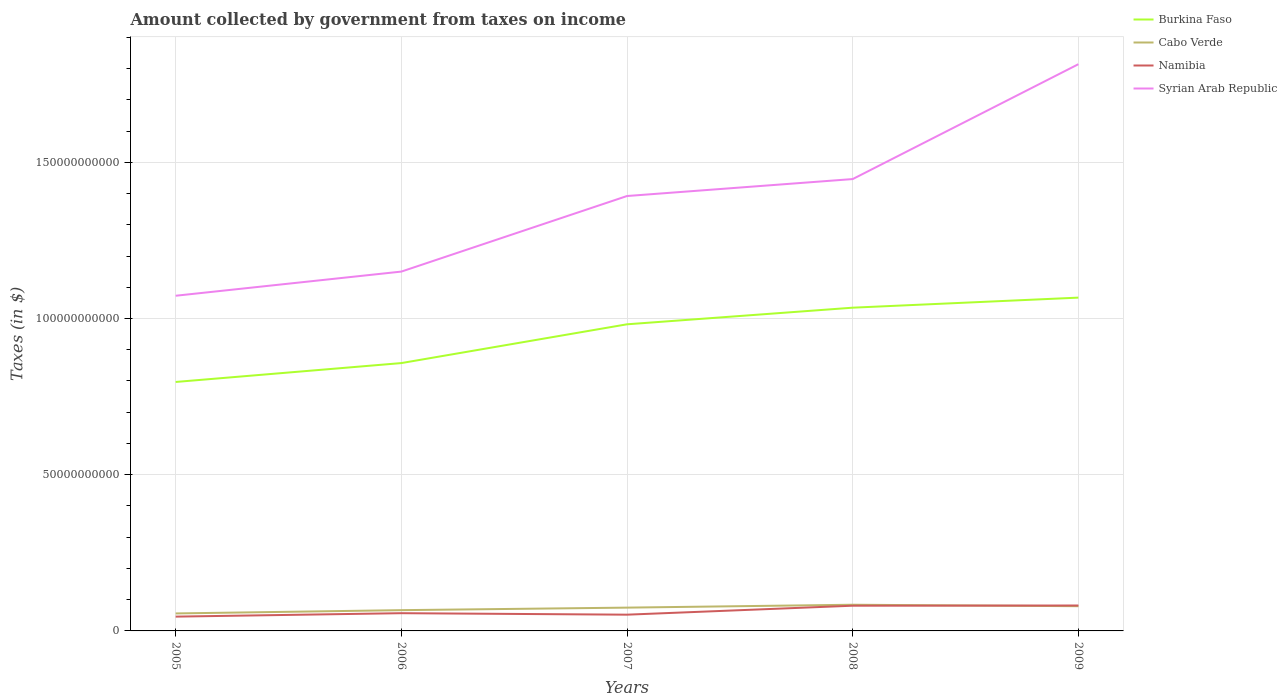How many different coloured lines are there?
Your answer should be very brief. 4. Does the line corresponding to Syrian Arab Republic intersect with the line corresponding to Namibia?
Ensure brevity in your answer.  No. Is the number of lines equal to the number of legend labels?
Ensure brevity in your answer.  Yes. Across all years, what is the maximum amount collected by government from taxes on income in Cabo Verde?
Keep it short and to the point. 5.60e+09. What is the total amount collected by government from taxes on income in Burkina Faso in the graph?
Ensure brevity in your answer.  -1.85e+1. What is the difference between the highest and the second highest amount collected by government from taxes on income in Syrian Arab Republic?
Keep it short and to the point. 7.41e+1. Is the amount collected by government from taxes on income in Cabo Verde strictly greater than the amount collected by government from taxes on income in Namibia over the years?
Provide a short and direct response. No. How many lines are there?
Offer a very short reply. 4. Are the values on the major ticks of Y-axis written in scientific E-notation?
Your answer should be very brief. No. Does the graph contain any zero values?
Provide a short and direct response. No. Where does the legend appear in the graph?
Your answer should be compact. Top right. How many legend labels are there?
Offer a very short reply. 4. What is the title of the graph?
Provide a short and direct response. Amount collected by government from taxes on income. Does "Singapore" appear as one of the legend labels in the graph?
Keep it short and to the point. No. What is the label or title of the Y-axis?
Keep it short and to the point. Taxes (in $). What is the Taxes (in $) of Burkina Faso in 2005?
Your response must be concise. 7.97e+1. What is the Taxes (in $) of Cabo Verde in 2005?
Offer a very short reply. 5.60e+09. What is the Taxes (in $) of Namibia in 2005?
Provide a succinct answer. 4.58e+09. What is the Taxes (in $) in Syrian Arab Republic in 2005?
Your answer should be compact. 1.07e+11. What is the Taxes (in $) in Burkina Faso in 2006?
Ensure brevity in your answer.  8.57e+1. What is the Taxes (in $) of Cabo Verde in 2006?
Give a very brief answer. 6.65e+09. What is the Taxes (in $) of Namibia in 2006?
Your response must be concise. 5.68e+09. What is the Taxes (in $) of Syrian Arab Republic in 2006?
Offer a terse response. 1.15e+11. What is the Taxes (in $) of Burkina Faso in 2007?
Offer a very short reply. 9.82e+1. What is the Taxes (in $) in Cabo Verde in 2007?
Offer a terse response. 7.46e+09. What is the Taxes (in $) of Namibia in 2007?
Your response must be concise. 5.20e+09. What is the Taxes (in $) of Syrian Arab Republic in 2007?
Make the answer very short. 1.39e+11. What is the Taxes (in $) in Burkina Faso in 2008?
Offer a terse response. 1.03e+11. What is the Taxes (in $) of Cabo Verde in 2008?
Your answer should be compact. 8.38e+09. What is the Taxes (in $) of Namibia in 2008?
Provide a succinct answer. 8.07e+09. What is the Taxes (in $) in Syrian Arab Republic in 2008?
Offer a very short reply. 1.45e+11. What is the Taxes (in $) of Burkina Faso in 2009?
Make the answer very short. 1.07e+11. What is the Taxes (in $) of Cabo Verde in 2009?
Make the answer very short. 7.91e+09. What is the Taxes (in $) in Namibia in 2009?
Your response must be concise. 8.14e+09. What is the Taxes (in $) of Syrian Arab Republic in 2009?
Make the answer very short. 1.81e+11. Across all years, what is the maximum Taxes (in $) in Burkina Faso?
Your response must be concise. 1.07e+11. Across all years, what is the maximum Taxes (in $) of Cabo Verde?
Offer a terse response. 8.38e+09. Across all years, what is the maximum Taxes (in $) of Namibia?
Your answer should be very brief. 8.14e+09. Across all years, what is the maximum Taxes (in $) of Syrian Arab Republic?
Your answer should be compact. 1.81e+11. Across all years, what is the minimum Taxes (in $) in Burkina Faso?
Offer a very short reply. 7.97e+1. Across all years, what is the minimum Taxes (in $) in Cabo Verde?
Ensure brevity in your answer.  5.60e+09. Across all years, what is the minimum Taxes (in $) of Namibia?
Make the answer very short. 4.58e+09. Across all years, what is the minimum Taxes (in $) in Syrian Arab Republic?
Provide a succinct answer. 1.07e+11. What is the total Taxes (in $) of Burkina Faso in the graph?
Your response must be concise. 4.74e+11. What is the total Taxes (in $) of Cabo Verde in the graph?
Make the answer very short. 3.60e+1. What is the total Taxes (in $) in Namibia in the graph?
Give a very brief answer. 3.17e+1. What is the total Taxes (in $) in Syrian Arab Republic in the graph?
Provide a short and direct response. 6.88e+11. What is the difference between the Taxes (in $) of Burkina Faso in 2005 and that in 2006?
Give a very brief answer. -6.05e+09. What is the difference between the Taxes (in $) of Cabo Verde in 2005 and that in 2006?
Give a very brief answer. -1.05e+09. What is the difference between the Taxes (in $) in Namibia in 2005 and that in 2006?
Give a very brief answer. -1.10e+09. What is the difference between the Taxes (in $) of Syrian Arab Republic in 2005 and that in 2006?
Your answer should be compact. -7.73e+09. What is the difference between the Taxes (in $) in Burkina Faso in 2005 and that in 2007?
Your response must be concise. -1.85e+1. What is the difference between the Taxes (in $) of Cabo Verde in 2005 and that in 2007?
Give a very brief answer. -1.86e+09. What is the difference between the Taxes (in $) in Namibia in 2005 and that in 2007?
Provide a succinct answer. -6.25e+08. What is the difference between the Taxes (in $) of Syrian Arab Republic in 2005 and that in 2007?
Provide a succinct answer. -3.19e+1. What is the difference between the Taxes (in $) of Burkina Faso in 2005 and that in 2008?
Provide a succinct answer. -2.38e+1. What is the difference between the Taxes (in $) in Cabo Verde in 2005 and that in 2008?
Give a very brief answer. -2.78e+09. What is the difference between the Taxes (in $) in Namibia in 2005 and that in 2008?
Provide a succinct answer. -3.49e+09. What is the difference between the Taxes (in $) in Syrian Arab Republic in 2005 and that in 2008?
Make the answer very short. -3.73e+1. What is the difference between the Taxes (in $) in Burkina Faso in 2005 and that in 2009?
Provide a short and direct response. -2.70e+1. What is the difference between the Taxes (in $) of Cabo Verde in 2005 and that in 2009?
Give a very brief answer. -2.31e+09. What is the difference between the Taxes (in $) of Namibia in 2005 and that in 2009?
Ensure brevity in your answer.  -3.56e+09. What is the difference between the Taxes (in $) in Syrian Arab Republic in 2005 and that in 2009?
Keep it short and to the point. -7.41e+1. What is the difference between the Taxes (in $) of Burkina Faso in 2006 and that in 2007?
Your answer should be compact. -1.24e+1. What is the difference between the Taxes (in $) in Cabo Verde in 2006 and that in 2007?
Keep it short and to the point. -8.07e+08. What is the difference between the Taxes (in $) in Namibia in 2006 and that in 2007?
Offer a terse response. 4.75e+08. What is the difference between the Taxes (in $) of Syrian Arab Republic in 2006 and that in 2007?
Your answer should be compact. -2.42e+1. What is the difference between the Taxes (in $) in Burkina Faso in 2006 and that in 2008?
Provide a short and direct response. -1.77e+1. What is the difference between the Taxes (in $) of Cabo Verde in 2006 and that in 2008?
Your response must be concise. -1.73e+09. What is the difference between the Taxes (in $) in Namibia in 2006 and that in 2008?
Your answer should be compact. -2.39e+09. What is the difference between the Taxes (in $) of Syrian Arab Republic in 2006 and that in 2008?
Make the answer very short. -2.96e+1. What is the difference between the Taxes (in $) in Burkina Faso in 2006 and that in 2009?
Your answer should be very brief. -2.09e+1. What is the difference between the Taxes (in $) in Cabo Verde in 2006 and that in 2009?
Offer a very short reply. -1.26e+09. What is the difference between the Taxes (in $) in Namibia in 2006 and that in 2009?
Provide a succinct answer. -2.46e+09. What is the difference between the Taxes (in $) in Syrian Arab Republic in 2006 and that in 2009?
Your answer should be very brief. -6.64e+1. What is the difference between the Taxes (in $) of Burkina Faso in 2007 and that in 2008?
Your answer should be compact. -5.32e+09. What is the difference between the Taxes (in $) in Cabo Verde in 2007 and that in 2008?
Your answer should be compact. -9.25e+08. What is the difference between the Taxes (in $) of Namibia in 2007 and that in 2008?
Your answer should be compact. -2.87e+09. What is the difference between the Taxes (in $) in Syrian Arab Republic in 2007 and that in 2008?
Keep it short and to the point. -5.43e+09. What is the difference between the Taxes (in $) of Burkina Faso in 2007 and that in 2009?
Your answer should be very brief. -8.54e+09. What is the difference between the Taxes (in $) of Cabo Verde in 2007 and that in 2009?
Your answer should be very brief. -4.55e+08. What is the difference between the Taxes (in $) in Namibia in 2007 and that in 2009?
Your answer should be very brief. -2.94e+09. What is the difference between the Taxes (in $) in Syrian Arab Republic in 2007 and that in 2009?
Your response must be concise. -4.22e+1. What is the difference between the Taxes (in $) of Burkina Faso in 2008 and that in 2009?
Your answer should be compact. -3.22e+09. What is the difference between the Taxes (in $) in Cabo Verde in 2008 and that in 2009?
Offer a very short reply. 4.70e+08. What is the difference between the Taxes (in $) of Namibia in 2008 and that in 2009?
Keep it short and to the point. -6.70e+07. What is the difference between the Taxes (in $) of Syrian Arab Republic in 2008 and that in 2009?
Offer a terse response. -3.68e+1. What is the difference between the Taxes (in $) in Burkina Faso in 2005 and the Taxes (in $) in Cabo Verde in 2006?
Make the answer very short. 7.30e+1. What is the difference between the Taxes (in $) of Burkina Faso in 2005 and the Taxes (in $) of Namibia in 2006?
Your response must be concise. 7.40e+1. What is the difference between the Taxes (in $) of Burkina Faso in 2005 and the Taxes (in $) of Syrian Arab Republic in 2006?
Offer a very short reply. -3.53e+1. What is the difference between the Taxes (in $) of Cabo Verde in 2005 and the Taxes (in $) of Namibia in 2006?
Your answer should be very brief. -7.93e+07. What is the difference between the Taxes (in $) in Cabo Verde in 2005 and the Taxes (in $) in Syrian Arab Republic in 2006?
Your answer should be compact. -1.09e+11. What is the difference between the Taxes (in $) in Namibia in 2005 and the Taxes (in $) in Syrian Arab Republic in 2006?
Ensure brevity in your answer.  -1.10e+11. What is the difference between the Taxes (in $) in Burkina Faso in 2005 and the Taxes (in $) in Cabo Verde in 2007?
Your answer should be very brief. 7.22e+1. What is the difference between the Taxes (in $) in Burkina Faso in 2005 and the Taxes (in $) in Namibia in 2007?
Your answer should be compact. 7.45e+1. What is the difference between the Taxes (in $) of Burkina Faso in 2005 and the Taxes (in $) of Syrian Arab Republic in 2007?
Your response must be concise. -5.95e+1. What is the difference between the Taxes (in $) of Cabo Verde in 2005 and the Taxes (in $) of Namibia in 2007?
Provide a succinct answer. 3.96e+08. What is the difference between the Taxes (in $) in Cabo Verde in 2005 and the Taxes (in $) in Syrian Arab Republic in 2007?
Your answer should be very brief. -1.34e+11. What is the difference between the Taxes (in $) in Namibia in 2005 and the Taxes (in $) in Syrian Arab Republic in 2007?
Your response must be concise. -1.35e+11. What is the difference between the Taxes (in $) of Burkina Faso in 2005 and the Taxes (in $) of Cabo Verde in 2008?
Your response must be concise. 7.13e+1. What is the difference between the Taxes (in $) in Burkina Faso in 2005 and the Taxes (in $) in Namibia in 2008?
Give a very brief answer. 7.16e+1. What is the difference between the Taxes (in $) in Burkina Faso in 2005 and the Taxes (in $) in Syrian Arab Republic in 2008?
Your answer should be compact. -6.49e+1. What is the difference between the Taxes (in $) in Cabo Verde in 2005 and the Taxes (in $) in Namibia in 2008?
Provide a succinct answer. -2.47e+09. What is the difference between the Taxes (in $) in Cabo Verde in 2005 and the Taxes (in $) in Syrian Arab Republic in 2008?
Keep it short and to the point. -1.39e+11. What is the difference between the Taxes (in $) of Namibia in 2005 and the Taxes (in $) of Syrian Arab Republic in 2008?
Your answer should be compact. -1.40e+11. What is the difference between the Taxes (in $) of Burkina Faso in 2005 and the Taxes (in $) of Cabo Verde in 2009?
Ensure brevity in your answer.  7.18e+1. What is the difference between the Taxes (in $) in Burkina Faso in 2005 and the Taxes (in $) in Namibia in 2009?
Offer a very short reply. 7.16e+1. What is the difference between the Taxes (in $) of Burkina Faso in 2005 and the Taxes (in $) of Syrian Arab Republic in 2009?
Make the answer very short. -1.02e+11. What is the difference between the Taxes (in $) of Cabo Verde in 2005 and the Taxes (in $) of Namibia in 2009?
Keep it short and to the point. -2.54e+09. What is the difference between the Taxes (in $) of Cabo Verde in 2005 and the Taxes (in $) of Syrian Arab Republic in 2009?
Keep it short and to the point. -1.76e+11. What is the difference between the Taxes (in $) of Namibia in 2005 and the Taxes (in $) of Syrian Arab Republic in 2009?
Make the answer very short. -1.77e+11. What is the difference between the Taxes (in $) of Burkina Faso in 2006 and the Taxes (in $) of Cabo Verde in 2007?
Your response must be concise. 7.83e+1. What is the difference between the Taxes (in $) in Burkina Faso in 2006 and the Taxes (in $) in Namibia in 2007?
Your answer should be compact. 8.05e+1. What is the difference between the Taxes (in $) in Burkina Faso in 2006 and the Taxes (in $) in Syrian Arab Republic in 2007?
Ensure brevity in your answer.  -5.35e+1. What is the difference between the Taxes (in $) in Cabo Verde in 2006 and the Taxes (in $) in Namibia in 2007?
Your response must be concise. 1.45e+09. What is the difference between the Taxes (in $) in Cabo Verde in 2006 and the Taxes (in $) in Syrian Arab Republic in 2007?
Ensure brevity in your answer.  -1.33e+11. What is the difference between the Taxes (in $) in Namibia in 2006 and the Taxes (in $) in Syrian Arab Republic in 2007?
Offer a very short reply. -1.34e+11. What is the difference between the Taxes (in $) of Burkina Faso in 2006 and the Taxes (in $) of Cabo Verde in 2008?
Make the answer very short. 7.74e+1. What is the difference between the Taxes (in $) of Burkina Faso in 2006 and the Taxes (in $) of Namibia in 2008?
Provide a succinct answer. 7.77e+1. What is the difference between the Taxes (in $) in Burkina Faso in 2006 and the Taxes (in $) in Syrian Arab Republic in 2008?
Give a very brief answer. -5.89e+1. What is the difference between the Taxes (in $) in Cabo Verde in 2006 and the Taxes (in $) in Namibia in 2008?
Keep it short and to the point. -1.42e+09. What is the difference between the Taxes (in $) in Cabo Verde in 2006 and the Taxes (in $) in Syrian Arab Republic in 2008?
Your answer should be very brief. -1.38e+11. What is the difference between the Taxes (in $) in Namibia in 2006 and the Taxes (in $) in Syrian Arab Republic in 2008?
Provide a succinct answer. -1.39e+11. What is the difference between the Taxes (in $) of Burkina Faso in 2006 and the Taxes (in $) of Cabo Verde in 2009?
Your answer should be very brief. 7.78e+1. What is the difference between the Taxes (in $) in Burkina Faso in 2006 and the Taxes (in $) in Namibia in 2009?
Offer a very short reply. 7.76e+1. What is the difference between the Taxes (in $) in Burkina Faso in 2006 and the Taxes (in $) in Syrian Arab Republic in 2009?
Your response must be concise. -9.57e+1. What is the difference between the Taxes (in $) in Cabo Verde in 2006 and the Taxes (in $) in Namibia in 2009?
Provide a short and direct response. -1.49e+09. What is the difference between the Taxes (in $) of Cabo Verde in 2006 and the Taxes (in $) of Syrian Arab Republic in 2009?
Make the answer very short. -1.75e+11. What is the difference between the Taxes (in $) in Namibia in 2006 and the Taxes (in $) in Syrian Arab Republic in 2009?
Ensure brevity in your answer.  -1.76e+11. What is the difference between the Taxes (in $) of Burkina Faso in 2007 and the Taxes (in $) of Cabo Verde in 2008?
Keep it short and to the point. 8.98e+1. What is the difference between the Taxes (in $) of Burkina Faso in 2007 and the Taxes (in $) of Namibia in 2008?
Your answer should be compact. 9.01e+1. What is the difference between the Taxes (in $) in Burkina Faso in 2007 and the Taxes (in $) in Syrian Arab Republic in 2008?
Ensure brevity in your answer.  -4.65e+1. What is the difference between the Taxes (in $) of Cabo Verde in 2007 and the Taxes (in $) of Namibia in 2008?
Keep it short and to the point. -6.14e+08. What is the difference between the Taxes (in $) of Cabo Verde in 2007 and the Taxes (in $) of Syrian Arab Republic in 2008?
Keep it short and to the point. -1.37e+11. What is the difference between the Taxes (in $) in Namibia in 2007 and the Taxes (in $) in Syrian Arab Republic in 2008?
Your response must be concise. -1.39e+11. What is the difference between the Taxes (in $) of Burkina Faso in 2007 and the Taxes (in $) of Cabo Verde in 2009?
Give a very brief answer. 9.02e+1. What is the difference between the Taxes (in $) in Burkina Faso in 2007 and the Taxes (in $) in Namibia in 2009?
Provide a succinct answer. 9.00e+1. What is the difference between the Taxes (in $) in Burkina Faso in 2007 and the Taxes (in $) in Syrian Arab Republic in 2009?
Ensure brevity in your answer.  -8.33e+1. What is the difference between the Taxes (in $) in Cabo Verde in 2007 and the Taxes (in $) in Namibia in 2009?
Provide a succinct answer. -6.81e+08. What is the difference between the Taxes (in $) in Cabo Verde in 2007 and the Taxes (in $) in Syrian Arab Republic in 2009?
Offer a terse response. -1.74e+11. What is the difference between the Taxes (in $) in Namibia in 2007 and the Taxes (in $) in Syrian Arab Republic in 2009?
Keep it short and to the point. -1.76e+11. What is the difference between the Taxes (in $) of Burkina Faso in 2008 and the Taxes (in $) of Cabo Verde in 2009?
Provide a succinct answer. 9.56e+1. What is the difference between the Taxes (in $) of Burkina Faso in 2008 and the Taxes (in $) of Namibia in 2009?
Your answer should be compact. 9.53e+1. What is the difference between the Taxes (in $) of Burkina Faso in 2008 and the Taxes (in $) of Syrian Arab Republic in 2009?
Offer a very short reply. -7.79e+1. What is the difference between the Taxes (in $) in Cabo Verde in 2008 and the Taxes (in $) in Namibia in 2009?
Your response must be concise. 2.44e+08. What is the difference between the Taxes (in $) of Cabo Verde in 2008 and the Taxes (in $) of Syrian Arab Republic in 2009?
Offer a very short reply. -1.73e+11. What is the difference between the Taxes (in $) of Namibia in 2008 and the Taxes (in $) of Syrian Arab Republic in 2009?
Offer a terse response. -1.73e+11. What is the average Taxes (in $) in Burkina Faso per year?
Offer a very short reply. 9.47e+1. What is the average Taxes (in $) in Cabo Verde per year?
Provide a short and direct response. 7.20e+09. What is the average Taxes (in $) in Namibia per year?
Offer a terse response. 6.33e+09. What is the average Taxes (in $) of Syrian Arab Republic per year?
Your answer should be compact. 1.38e+11. In the year 2005, what is the difference between the Taxes (in $) of Burkina Faso and Taxes (in $) of Cabo Verde?
Offer a terse response. 7.41e+1. In the year 2005, what is the difference between the Taxes (in $) of Burkina Faso and Taxes (in $) of Namibia?
Your response must be concise. 7.51e+1. In the year 2005, what is the difference between the Taxes (in $) of Burkina Faso and Taxes (in $) of Syrian Arab Republic?
Offer a terse response. -2.76e+1. In the year 2005, what is the difference between the Taxes (in $) of Cabo Verde and Taxes (in $) of Namibia?
Ensure brevity in your answer.  1.02e+09. In the year 2005, what is the difference between the Taxes (in $) in Cabo Verde and Taxes (in $) in Syrian Arab Republic?
Ensure brevity in your answer.  -1.02e+11. In the year 2005, what is the difference between the Taxes (in $) of Namibia and Taxes (in $) of Syrian Arab Republic?
Keep it short and to the point. -1.03e+11. In the year 2006, what is the difference between the Taxes (in $) of Burkina Faso and Taxes (in $) of Cabo Verde?
Offer a very short reply. 7.91e+1. In the year 2006, what is the difference between the Taxes (in $) in Burkina Faso and Taxes (in $) in Namibia?
Make the answer very short. 8.01e+1. In the year 2006, what is the difference between the Taxes (in $) in Burkina Faso and Taxes (in $) in Syrian Arab Republic?
Offer a terse response. -2.93e+1. In the year 2006, what is the difference between the Taxes (in $) of Cabo Verde and Taxes (in $) of Namibia?
Offer a very short reply. 9.72e+08. In the year 2006, what is the difference between the Taxes (in $) in Cabo Verde and Taxes (in $) in Syrian Arab Republic?
Your answer should be very brief. -1.08e+11. In the year 2006, what is the difference between the Taxes (in $) of Namibia and Taxes (in $) of Syrian Arab Republic?
Your answer should be very brief. -1.09e+11. In the year 2007, what is the difference between the Taxes (in $) in Burkina Faso and Taxes (in $) in Cabo Verde?
Provide a short and direct response. 9.07e+1. In the year 2007, what is the difference between the Taxes (in $) in Burkina Faso and Taxes (in $) in Namibia?
Provide a short and direct response. 9.29e+1. In the year 2007, what is the difference between the Taxes (in $) in Burkina Faso and Taxes (in $) in Syrian Arab Republic?
Provide a succinct answer. -4.11e+1. In the year 2007, what is the difference between the Taxes (in $) in Cabo Verde and Taxes (in $) in Namibia?
Your answer should be very brief. 2.25e+09. In the year 2007, what is the difference between the Taxes (in $) in Cabo Verde and Taxes (in $) in Syrian Arab Republic?
Make the answer very short. -1.32e+11. In the year 2007, what is the difference between the Taxes (in $) of Namibia and Taxes (in $) of Syrian Arab Republic?
Provide a short and direct response. -1.34e+11. In the year 2008, what is the difference between the Taxes (in $) in Burkina Faso and Taxes (in $) in Cabo Verde?
Offer a terse response. 9.51e+1. In the year 2008, what is the difference between the Taxes (in $) in Burkina Faso and Taxes (in $) in Namibia?
Your response must be concise. 9.54e+1. In the year 2008, what is the difference between the Taxes (in $) of Burkina Faso and Taxes (in $) of Syrian Arab Republic?
Keep it short and to the point. -4.12e+1. In the year 2008, what is the difference between the Taxes (in $) in Cabo Verde and Taxes (in $) in Namibia?
Provide a short and direct response. 3.11e+08. In the year 2008, what is the difference between the Taxes (in $) in Cabo Verde and Taxes (in $) in Syrian Arab Republic?
Provide a short and direct response. -1.36e+11. In the year 2008, what is the difference between the Taxes (in $) in Namibia and Taxes (in $) in Syrian Arab Republic?
Give a very brief answer. -1.37e+11. In the year 2009, what is the difference between the Taxes (in $) in Burkina Faso and Taxes (in $) in Cabo Verde?
Make the answer very short. 9.88e+1. In the year 2009, what is the difference between the Taxes (in $) of Burkina Faso and Taxes (in $) of Namibia?
Your response must be concise. 9.85e+1. In the year 2009, what is the difference between the Taxes (in $) of Burkina Faso and Taxes (in $) of Syrian Arab Republic?
Your answer should be compact. -7.47e+1. In the year 2009, what is the difference between the Taxes (in $) in Cabo Verde and Taxes (in $) in Namibia?
Provide a short and direct response. -2.26e+08. In the year 2009, what is the difference between the Taxes (in $) in Cabo Verde and Taxes (in $) in Syrian Arab Republic?
Provide a short and direct response. -1.73e+11. In the year 2009, what is the difference between the Taxes (in $) of Namibia and Taxes (in $) of Syrian Arab Republic?
Your answer should be very brief. -1.73e+11. What is the ratio of the Taxes (in $) of Burkina Faso in 2005 to that in 2006?
Your answer should be very brief. 0.93. What is the ratio of the Taxes (in $) of Cabo Verde in 2005 to that in 2006?
Offer a terse response. 0.84. What is the ratio of the Taxes (in $) in Namibia in 2005 to that in 2006?
Keep it short and to the point. 0.81. What is the ratio of the Taxes (in $) in Syrian Arab Republic in 2005 to that in 2006?
Offer a terse response. 0.93. What is the ratio of the Taxes (in $) of Burkina Faso in 2005 to that in 2007?
Offer a very short reply. 0.81. What is the ratio of the Taxes (in $) in Cabo Verde in 2005 to that in 2007?
Make the answer very short. 0.75. What is the ratio of the Taxes (in $) of Namibia in 2005 to that in 2007?
Provide a succinct answer. 0.88. What is the ratio of the Taxes (in $) of Syrian Arab Republic in 2005 to that in 2007?
Keep it short and to the point. 0.77. What is the ratio of the Taxes (in $) of Burkina Faso in 2005 to that in 2008?
Give a very brief answer. 0.77. What is the ratio of the Taxes (in $) in Cabo Verde in 2005 to that in 2008?
Your answer should be compact. 0.67. What is the ratio of the Taxes (in $) in Namibia in 2005 to that in 2008?
Offer a terse response. 0.57. What is the ratio of the Taxes (in $) of Syrian Arab Republic in 2005 to that in 2008?
Give a very brief answer. 0.74. What is the ratio of the Taxes (in $) of Burkina Faso in 2005 to that in 2009?
Make the answer very short. 0.75. What is the ratio of the Taxes (in $) of Cabo Verde in 2005 to that in 2009?
Your answer should be very brief. 0.71. What is the ratio of the Taxes (in $) in Namibia in 2005 to that in 2009?
Your answer should be compact. 0.56. What is the ratio of the Taxes (in $) of Syrian Arab Republic in 2005 to that in 2009?
Ensure brevity in your answer.  0.59. What is the ratio of the Taxes (in $) of Burkina Faso in 2006 to that in 2007?
Give a very brief answer. 0.87. What is the ratio of the Taxes (in $) of Cabo Verde in 2006 to that in 2007?
Keep it short and to the point. 0.89. What is the ratio of the Taxes (in $) of Namibia in 2006 to that in 2007?
Your answer should be compact. 1.09. What is the ratio of the Taxes (in $) of Syrian Arab Republic in 2006 to that in 2007?
Your answer should be compact. 0.83. What is the ratio of the Taxes (in $) in Burkina Faso in 2006 to that in 2008?
Your answer should be compact. 0.83. What is the ratio of the Taxes (in $) in Cabo Verde in 2006 to that in 2008?
Offer a terse response. 0.79. What is the ratio of the Taxes (in $) in Namibia in 2006 to that in 2008?
Your answer should be compact. 0.7. What is the ratio of the Taxes (in $) in Syrian Arab Republic in 2006 to that in 2008?
Your answer should be compact. 0.8. What is the ratio of the Taxes (in $) in Burkina Faso in 2006 to that in 2009?
Your answer should be very brief. 0.8. What is the ratio of the Taxes (in $) in Cabo Verde in 2006 to that in 2009?
Your answer should be compact. 0.84. What is the ratio of the Taxes (in $) in Namibia in 2006 to that in 2009?
Ensure brevity in your answer.  0.7. What is the ratio of the Taxes (in $) of Syrian Arab Republic in 2006 to that in 2009?
Provide a succinct answer. 0.63. What is the ratio of the Taxes (in $) of Burkina Faso in 2007 to that in 2008?
Offer a terse response. 0.95. What is the ratio of the Taxes (in $) of Cabo Verde in 2007 to that in 2008?
Offer a very short reply. 0.89. What is the ratio of the Taxes (in $) in Namibia in 2007 to that in 2008?
Provide a succinct answer. 0.64. What is the ratio of the Taxes (in $) in Syrian Arab Republic in 2007 to that in 2008?
Provide a short and direct response. 0.96. What is the ratio of the Taxes (in $) in Cabo Verde in 2007 to that in 2009?
Provide a succinct answer. 0.94. What is the ratio of the Taxes (in $) in Namibia in 2007 to that in 2009?
Give a very brief answer. 0.64. What is the ratio of the Taxes (in $) of Syrian Arab Republic in 2007 to that in 2009?
Your answer should be very brief. 0.77. What is the ratio of the Taxes (in $) of Burkina Faso in 2008 to that in 2009?
Give a very brief answer. 0.97. What is the ratio of the Taxes (in $) of Cabo Verde in 2008 to that in 2009?
Your answer should be compact. 1.06. What is the ratio of the Taxes (in $) in Namibia in 2008 to that in 2009?
Ensure brevity in your answer.  0.99. What is the ratio of the Taxes (in $) in Syrian Arab Republic in 2008 to that in 2009?
Make the answer very short. 0.8. What is the difference between the highest and the second highest Taxes (in $) in Burkina Faso?
Ensure brevity in your answer.  3.22e+09. What is the difference between the highest and the second highest Taxes (in $) in Cabo Verde?
Give a very brief answer. 4.70e+08. What is the difference between the highest and the second highest Taxes (in $) of Namibia?
Provide a succinct answer. 6.70e+07. What is the difference between the highest and the second highest Taxes (in $) in Syrian Arab Republic?
Your answer should be very brief. 3.68e+1. What is the difference between the highest and the lowest Taxes (in $) in Burkina Faso?
Keep it short and to the point. 2.70e+1. What is the difference between the highest and the lowest Taxes (in $) in Cabo Verde?
Your answer should be compact. 2.78e+09. What is the difference between the highest and the lowest Taxes (in $) in Namibia?
Make the answer very short. 3.56e+09. What is the difference between the highest and the lowest Taxes (in $) in Syrian Arab Republic?
Provide a short and direct response. 7.41e+1. 